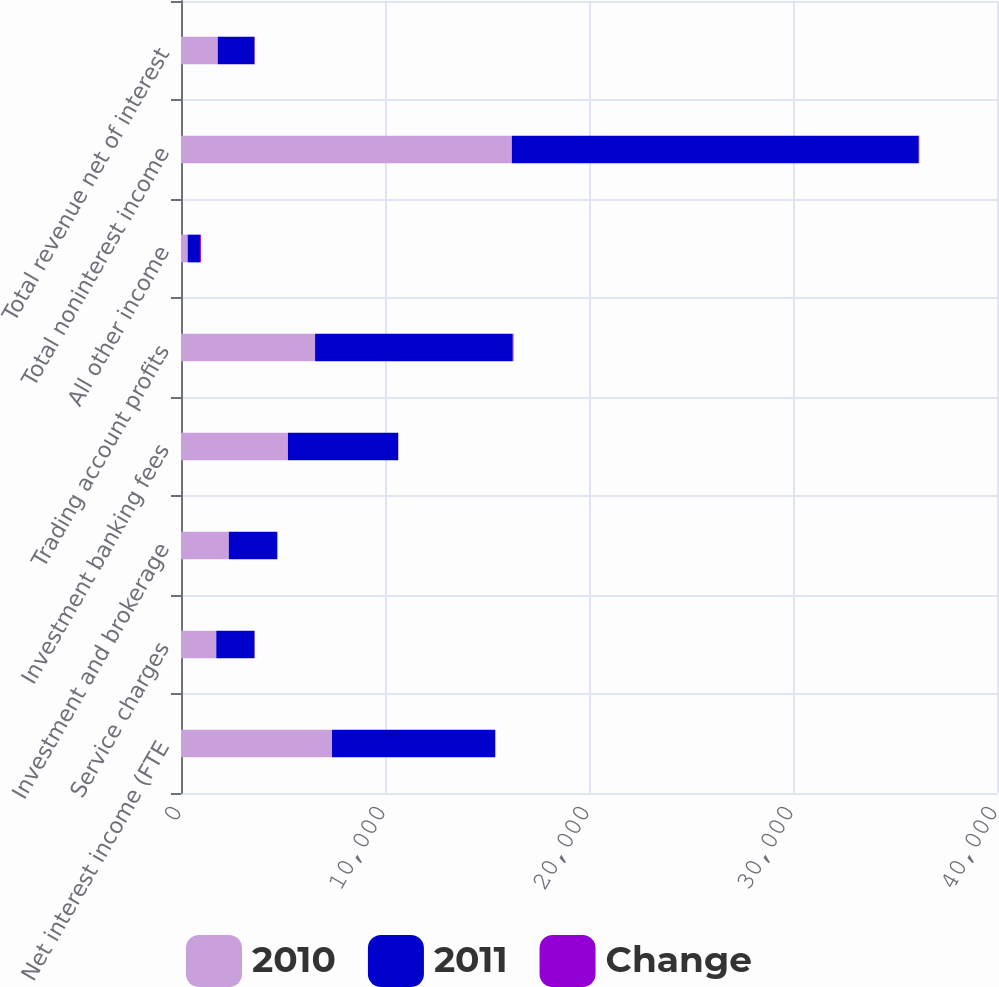Convert chart to OTSL. <chart><loc_0><loc_0><loc_500><loc_500><stacked_bar_chart><ecel><fcel>Net interest income (FTE<fcel>Service charges<fcel>Investment and brokerage<fcel>Investment banking fees<fcel>Trading account profits<fcel>All other income<fcel>Total noninterest income<fcel>Total revenue net of interest<nl><fcel>2010<fcel>7401<fcel>1730<fcel>2345<fcel>5242<fcel>6573<fcel>327<fcel>16217<fcel>1802<nl><fcel>2011<fcel>8000<fcel>1874<fcel>2377<fcel>5406<fcel>9689<fcel>603<fcel>19949<fcel>1802<nl><fcel>Change<fcel>7<fcel>8<fcel>1<fcel>3<fcel>32<fcel>46<fcel>19<fcel>15<nl></chart> 